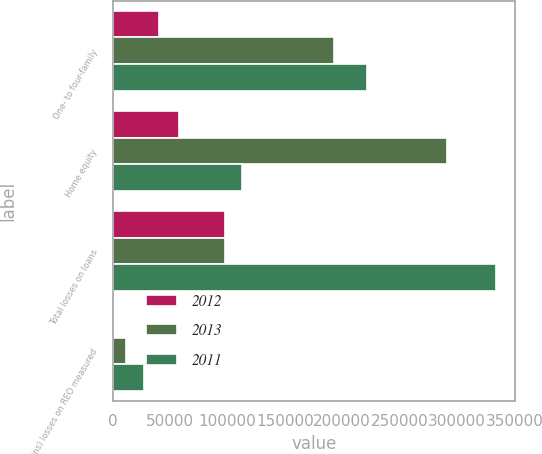Convert chart to OTSL. <chart><loc_0><loc_0><loc_500><loc_500><stacked_bar_chart><ecel><fcel>One- to four-family<fcel>Home equity<fcel>Total losses on loans<fcel>(Gains) losses on REO measured<nl><fcel>2012<fcel>40047<fcel>57626<fcel>97673<fcel>565<nl><fcel>2013<fcel>193250<fcel>291316<fcel>97673<fcel>12068<nl><fcel>2011<fcel>221717<fcel>112426<fcel>334143<fcel>27582<nl></chart> 